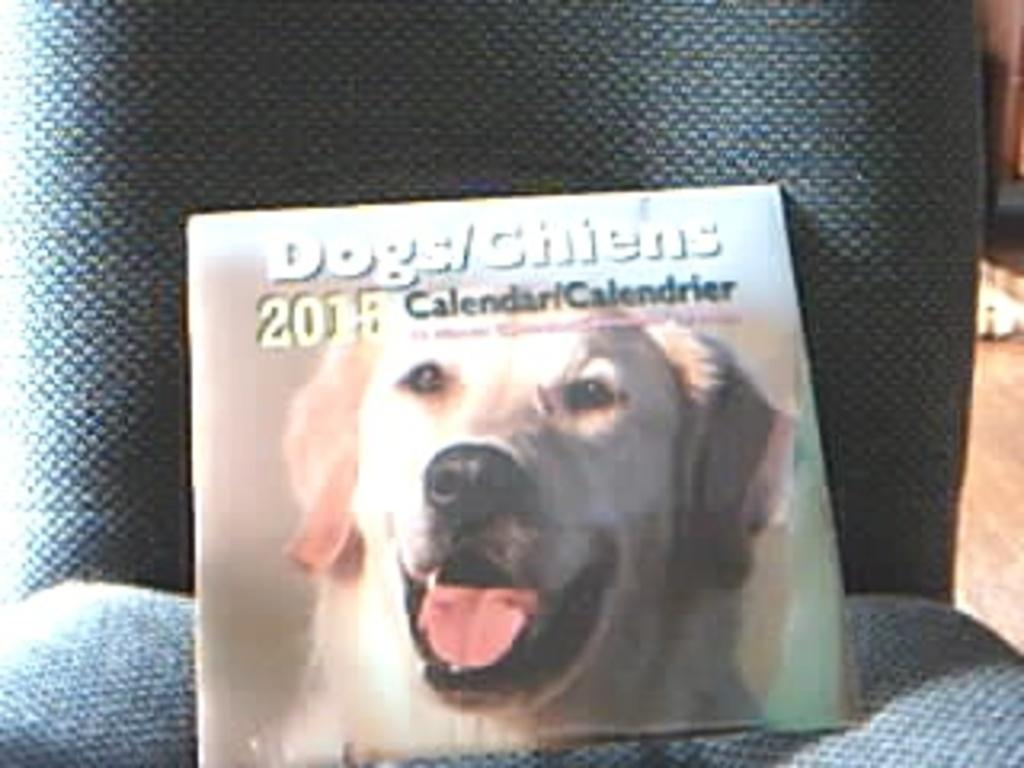What type of object is present in the image that is used for tracking dates? There is a calendar in the image that is used for tracking dates. What image is featured on the calendar? The calendar has an image of a dog. What can be found written on the calendar? There is text written on the calendar. What colors are visible on the surface where the calendar is placed? The calendar is on a blue and green color surface. What type of bag is visible in the image? There is no bag present in the image. What is the temperature of the ice in the image? There is no ice present in the image. 